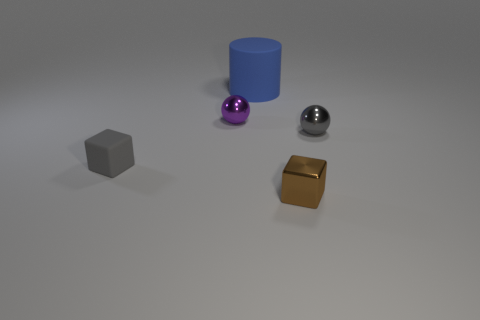Can you tell me the colors of the objects shown in the image? Certainly! The image displays objects in various colors: there is a gray cube, a blue cylinder, a purple sphere, a silver metallic ball, and a golden cube. 